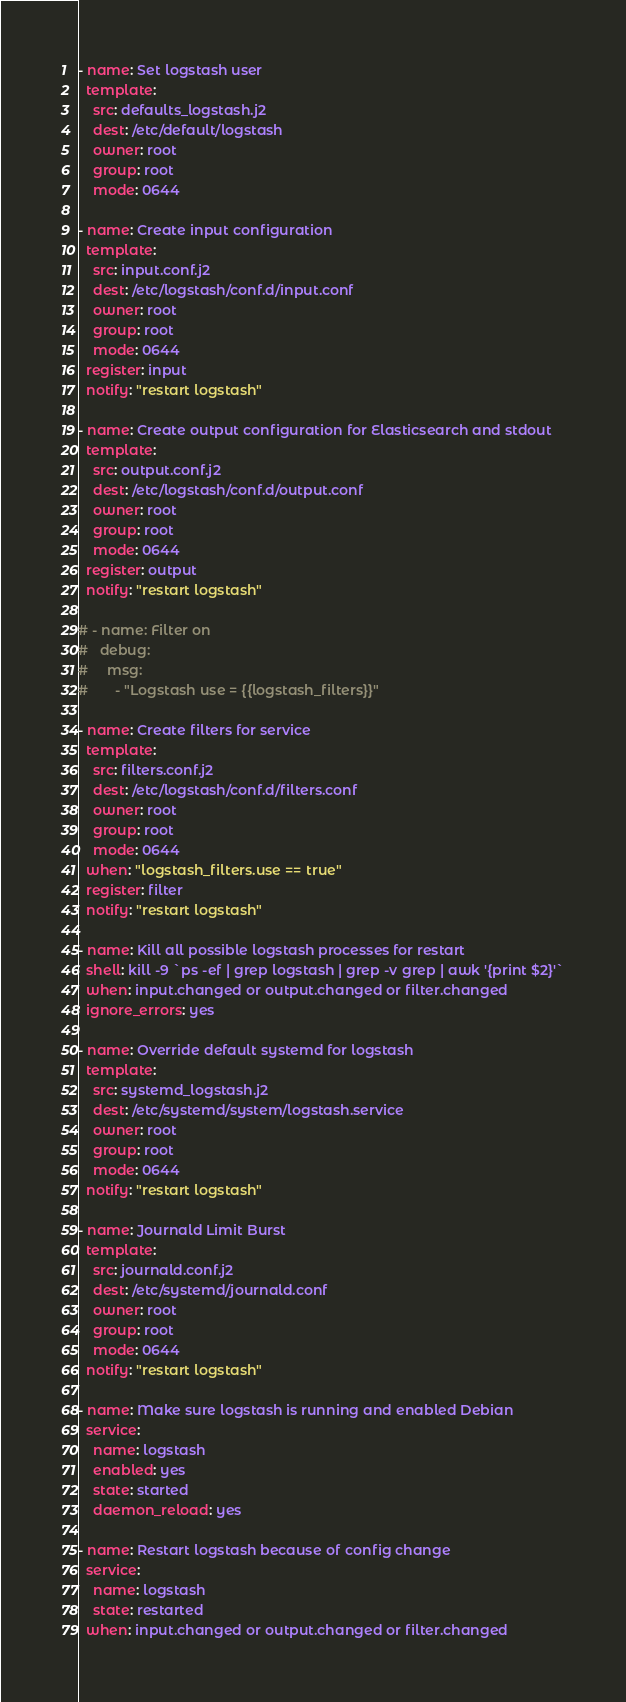<code> <loc_0><loc_0><loc_500><loc_500><_YAML_>- name: Set logstash user
  template:
    src: defaults_logstash.j2
    dest: /etc/default/logstash
    owner: root
    group: root
    mode: 0644

- name: Create input configuration
  template:
    src: input.conf.j2
    dest: /etc/logstash/conf.d/input.conf
    owner: root
    group: root
    mode: 0644
  register: input
  notify: "restart logstash"

- name: Create output configuration for Elasticsearch and stdout
  template:
    src: output.conf.j2
    dest: /etc/logstash/conf.d/output.conf
    owner: root
    group: root
    mode: 0644
  register: output
  notify: "restart logstash"

# - name: Filter on
#   debug:
#     msg:
#       - "Logstash use = {{logstash_filters}}"

- name: Create filters for service
  template:
    src: filters.conf.j2
    dest: /etc/logstash/conf.d/filters.conf
    owner: root
    group: root
    mode: 0644
  when: "logstash_filters.use == true"
  register: filter
  notify: "restart logstash"

- name: Kill all possible logstash processes for restart
  shell: kill -9 `ps -ef | grep logstash | grep -v grep | awk '{print $2}'`
  when: input.changed or output.changed or filter.changed
  ignore_errors: yes

- name: Override default systemd for logstash
  template:
    src: systemd_logstash.j2
    dest: /etc/systemd/system/logstash.service
    owner: root
    group: root
    mode: 0644
  notify: "restart logstash"

- name: Journald Limit Burst
  template:
    src: journald.conf.j2
    dest: /etc/systemd/journald.conf
    owner: root
    group: root
    mode: 0644
  notify: "restart logstash"

- name: Make sure logstash is running and enabled Debian
  service:
    name: logstash
    enabled: yes
    state: started
    daemon_reload: yes

- name: Restart logstash because of config change
  service:
    name: logstash
    state: restarted
  when: input.changed or output.changed or filter.changed
</code> 